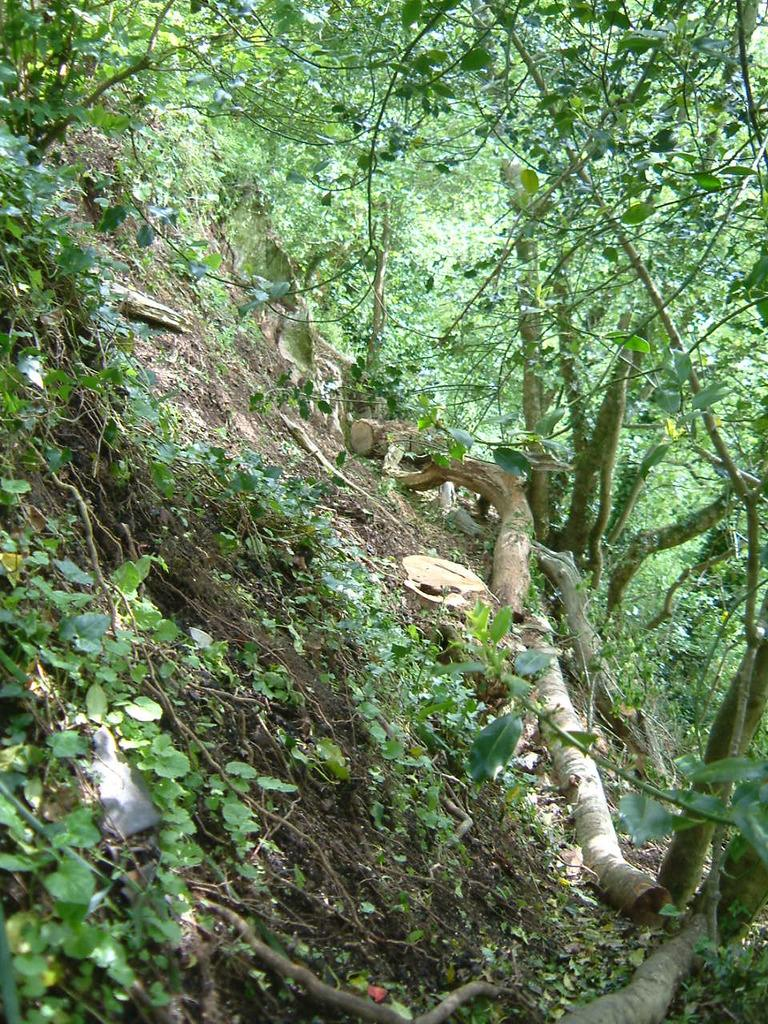What type of vegetation can be seen in the image? There are a few trees in the image. What type of flooring can be seen beneath the trees in the image? There is no flooring visible in the image, as it features trees and no other structures or surfaces. 